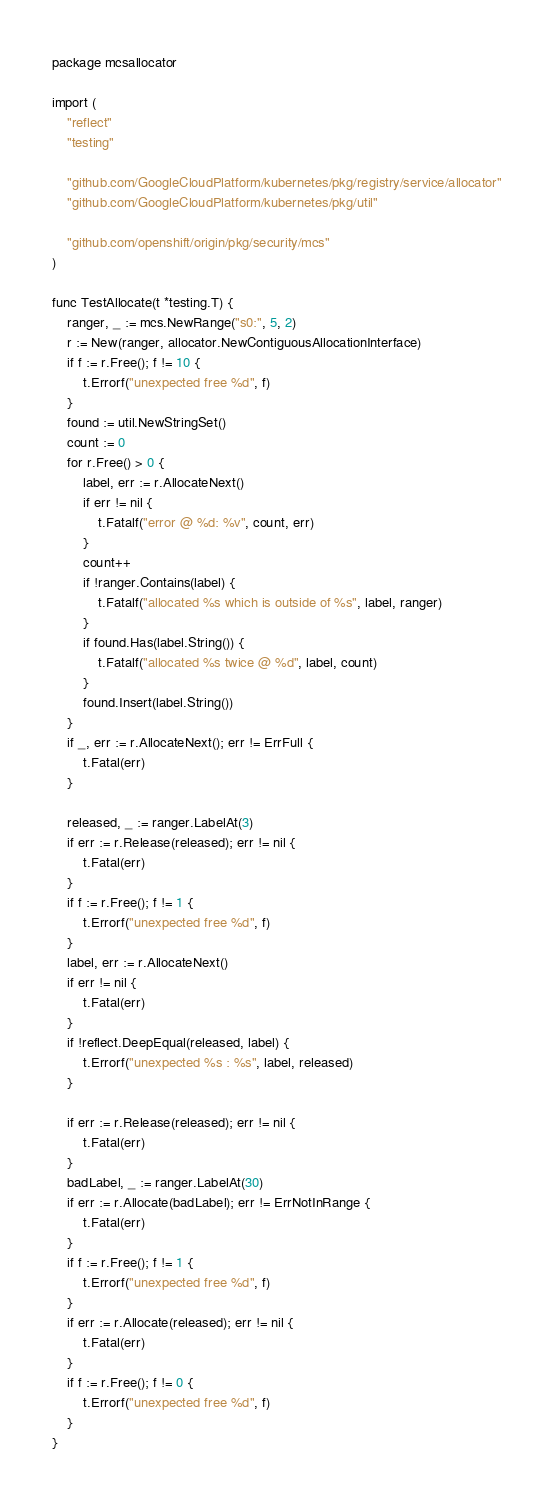<code> <loc_0><loc_0><loc_500><loc_500><_Go_>package mcsallocator

import (
	"reflect"
	"testing"

	"github.com/GoogleCloudPlatform/kubernetes/pkg/registry/service/allocator"
	"github.com/GoogleCloudPlatform/kubernetes/pkg/util"

	"github.com/openshift/origin/pkg/security/mcs"
)

func TestAllocate(t *testing.T) {
	ranger, _ := mcs.NewRange("s0:", 5, 2)
	r := New(ranger, allocator.NewContiguousAllocationInterface)
	if f := r.Free(); f != 10 {
		t.Errorf("unexpected free %d", f)
	}
	found := util.NewStringSet()
	count := 0
	for r.Free() > 0 {
		label, err := r.AllocateNext()
		if err != nil {
			t.Fatalf("error @ %d: %v", count, err)
		}
		count++
		if !ranger.Contains(label) {
			t.Fatalf("allocated %s which is outside of %s", label, ranger)
		}
		if found.Has(label.String()) {
			t.Fatalf("allocated %s twice @ %d", label, count)
		}
		found.Insert(label.String())
	}
	if _, err := r.AllocateNext(); err != ErrFull {
		t.Fatal(err)
	}

	released, _ := ranger.LabelAt(3)
	if err := r.Release(released); err != nil {
		t.Fatal(err)
	}
	if f := r.Free(); f != 1 {
		t.Errorf("unexpected free %d", f)
	}
	label, err := r.AllocateNext()
	if err != nil {
		t.Fatal(err)
	}
	if !reflect.DeepEqual(released, label) {
		t.Errorf("unexpected %s : %s", label, released)
	}

	if err := r.Release(released); err != nil {
		t.Fatal(err)
	}
	badLabel, _ := ranger.LabelAt(30)
	if err := r.Allocate(badLabel); err != ErrNotInRange {
		t.Fatal(err)
	}
	if f := r.Free(); f != 1 {
		t.Errorf("unexpected free %d", f)
	}
	if err := r.Allocate(released); err != nil {
		t.Fatal(err)
	}
	if f := r.Free(); f != 0 {
		t.Errorf("unexpected free %d", f)
	}
}
</code> 